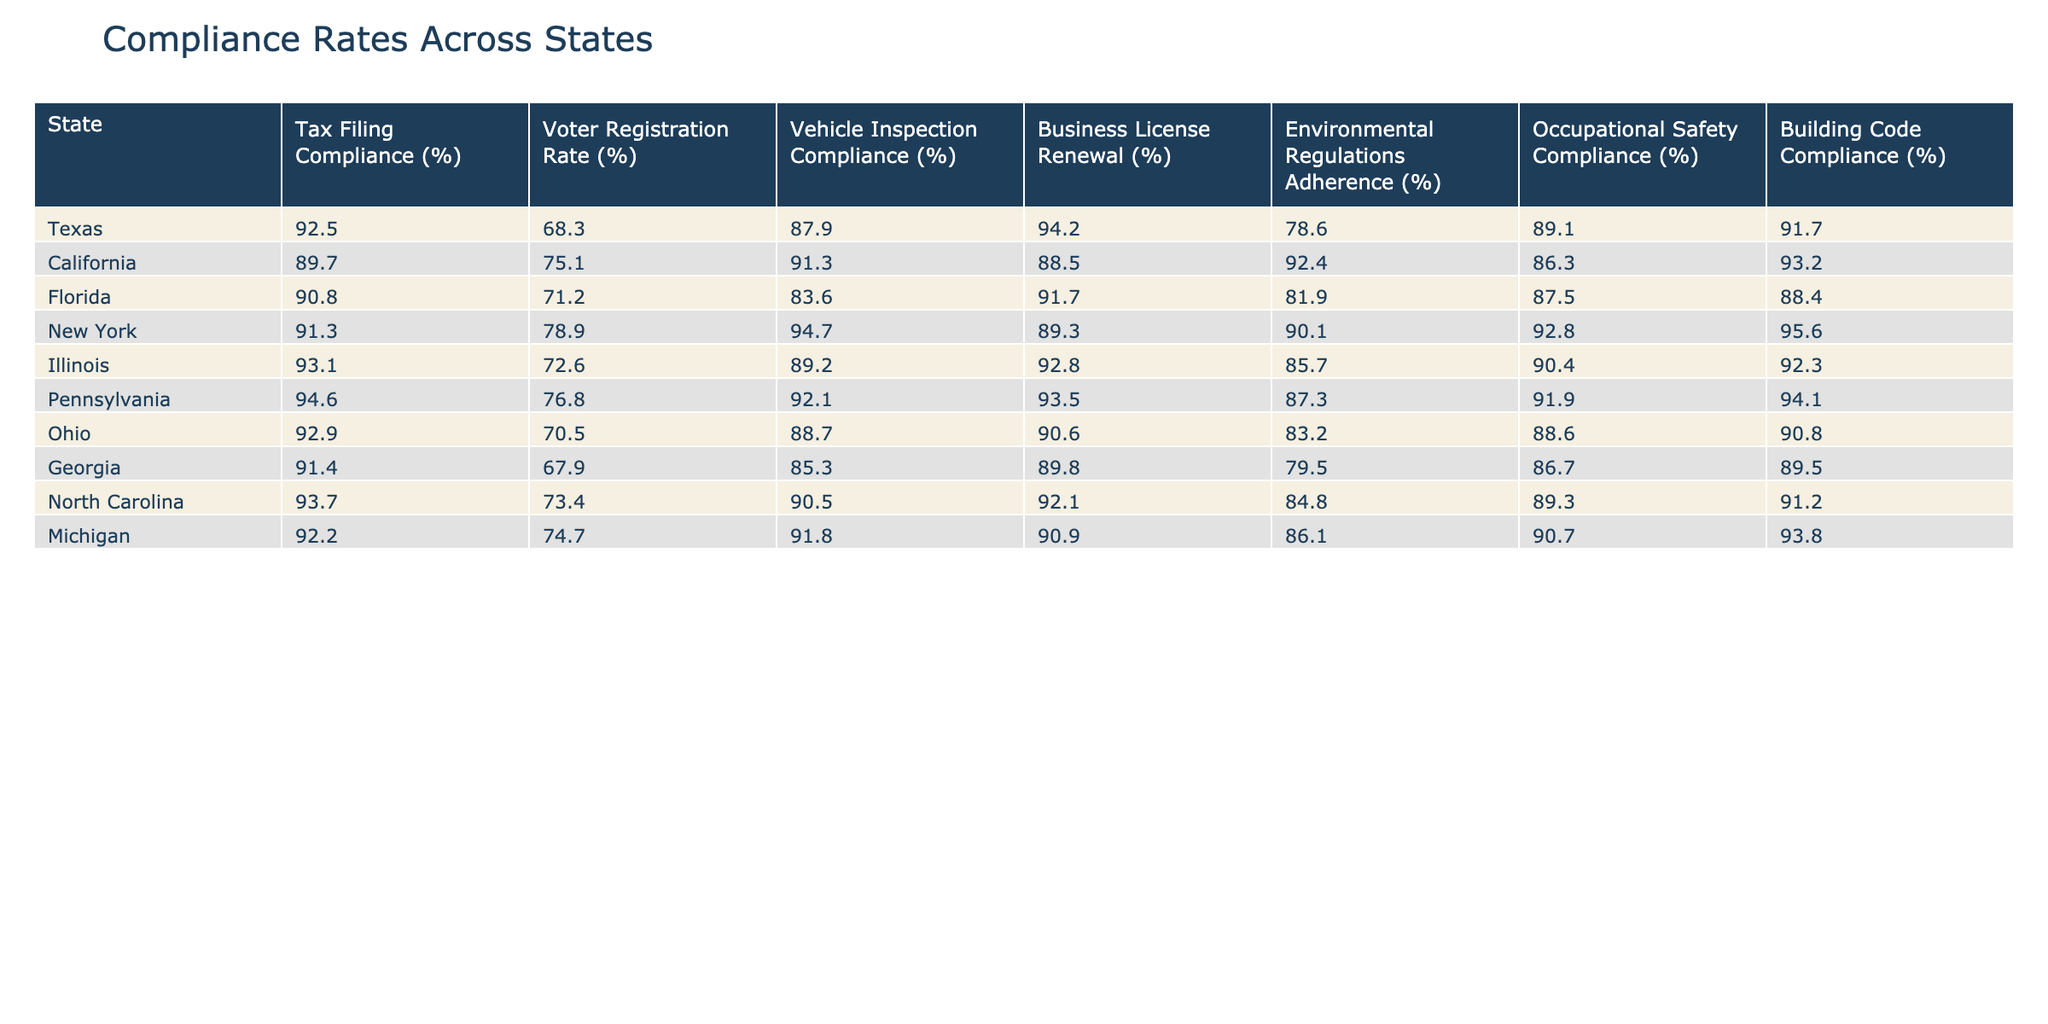What is the Tax Filing Compliance rate for California? The table shows that California's Tax Filing Compliance rate is listed as 89.7%.
Answer: 89.7% Which state has the highest Environmental Regulations Adherence? By examining the Environmental Regulations Adherence column, Pennsylvania has the highest rate at 94.6%.
Answer: 94.6% What is the average Vehicle Inspection Compliance rate across all states listed? The Vehicle Inspection Compliance rates are 87.9, 91.3, 83.6, 94.7, 89.2, 92.1, 88.7, 85.3, 90.5, and 91.8. Adding these rates gives 900.8, and dividing by 10 (the number of states) results in an average of 90.08%.
Answer: 90.08% Does Ohio have a higher Business License Renewal compliance rate than Georgia? Ohio's Business License Renewal rate is 90.6%, while Georgia's is 89.8%. Since 90.6% is greater than 89.8%, the statement is true.
Answer: Yes Which state has the lowest Voter Registration Rate, and what is that rate? Reviewing the Voter Registration Rate column, Georgia has the lowest at 67.9%.
Answer: 67.9% If a state has a Tax Filing Compliance rate of 92%, what is the corresponding compliance rate for Occupational Safety in that state based on the table? Referring to the state of Texas, which has a Tax Filing Compliance rate of 92.5%, the corresponding Occupational Safety Compliance rate is 89.1%.
Answer: 89.1% Which state has a better compliance rate in Business License Renewal: Illinois or Texas? Texas has a Business License Renewal rate of 94.2%, while Illinois has 92.8%. Comparing these rates shows that Texas has a better compliance rate.
Answer: Texas What is the difference between the highest and lowest compliance rates for Building Code Compliance among the states? The Building Code Compliance rates are 91.7 (Texas) and 88.4 (Florida), respectively. The difference is 91.7 - 88.4 = 3.3%.
Answer: 3.3% Is the Tax Filing Compliance rate for Florida less than the average rate of all states? The average Tax Filing Compliance rate is (92.5 + 89.7 + 90.8 + 91.3 + 93.1 + 94.6 + 92.9 + 91.4 + 93.7 + 92.2)/10 = 92.0%. Florida's rate of 90.8% is less than the average.
Answer: Yes Which two states have the closest Environmental Regulations Adherence rates? California has 92.4% and Michigan has 86.1%. The difference between them is 6.3%, which is the smallest compared to the others.
Answer: California and Michigan 